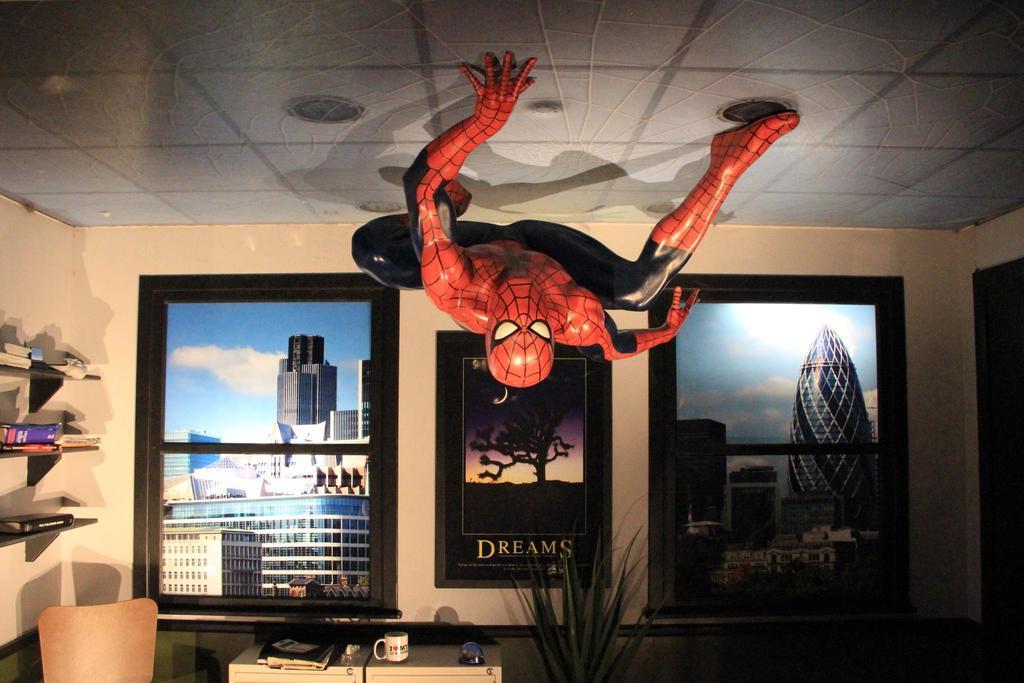In one or two sentences, can you explain what this image depicts? In this image there is a spider man upside down, there are three frames attached to the wall in which there are buildings and sky in two frames and a tree and some text in the third frame, there are books arranged in the shelf's, a book, glass and some other objects on the table, there is a plant. 